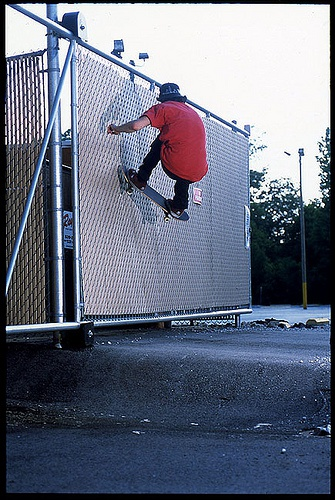Describe the objects in this image and their specific colors. I can see people in black, brown, and maroon tones and skateboard in black, darkblue, navy, and gray tones in this image. 